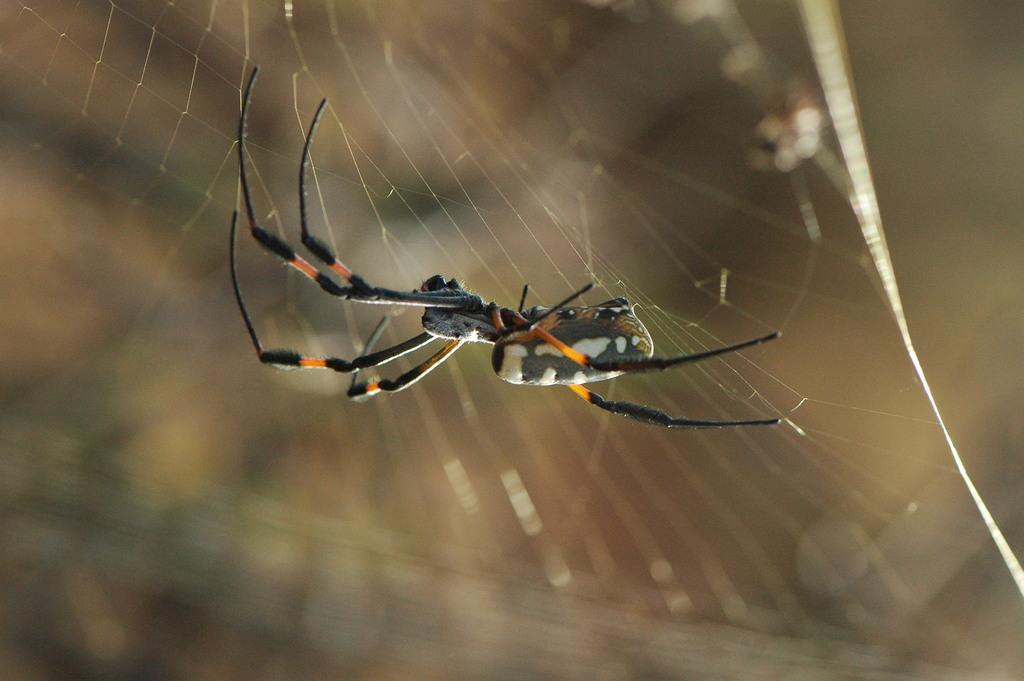Describe this image in one or two sentences. In the center of the image there is a spider and a spider web. 